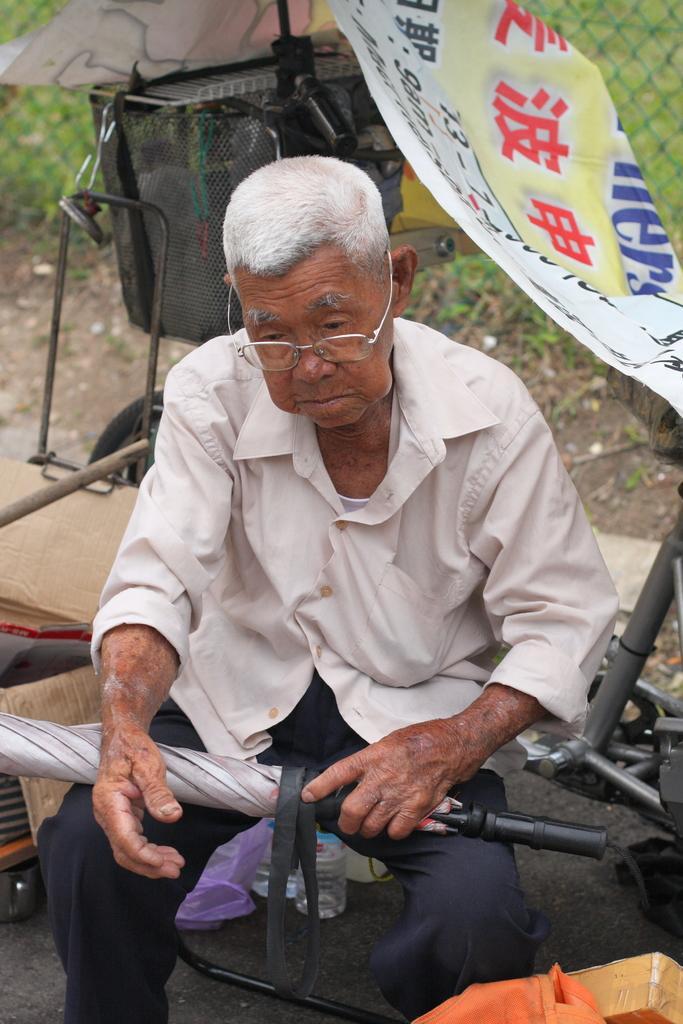Could you give a brief overview of what you see in this image? In this picture I see a man in front who is wearing cream color shirt and black pants and I see that he is holding a thing and in the background I see the banner on which there is something written and I see a cycle. 